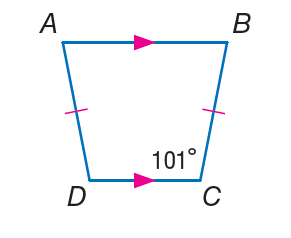Question: Find m \angle D.
Choices:
A. 45
B. 79
C. 101
D. 182
Answer with the letter. Answer: C 